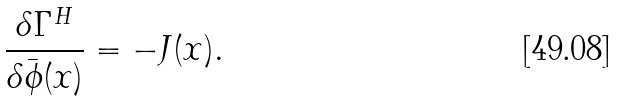<formula> <loc_0><loc_0><loc_500><loc_500>\frac { \delta \Gamma ^ { H } } { \delta \bar { \phi } ( x ) } = - J ( x ) .</formula> 